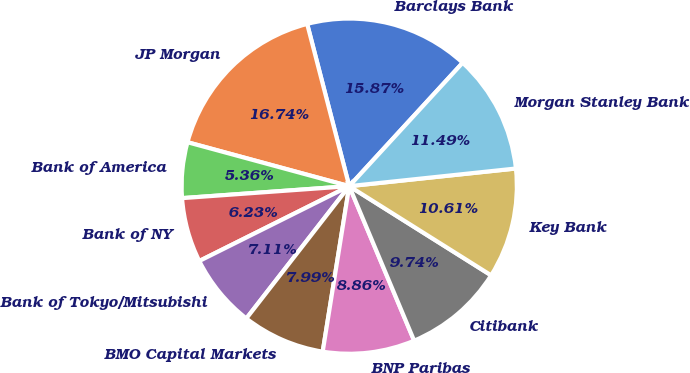<chart> <loc_0><loc_0><loc_500><loc_500><pie_chart><fcel>Barclays Bank<fcel>JP Morgan<fcel>Bank of America<fcel>Bank of NY<fcel>Bank of Tokyo/Mitsubishi<fcel>BMO Capital Markets<fcel>BNP Paribas<fcel>Citibank<fcel>Key Bank<fcel>Morgan Stanley Bank<nl><fcel>15.87%<fcel>16.74%<fcel>5.36%<fcel>6.23%<fcel>7.11%<fcel>7.99%<fcel>8.86%<fcel>9.74%<fcel>10.61%<fcel>11.49%<nl></chart> 